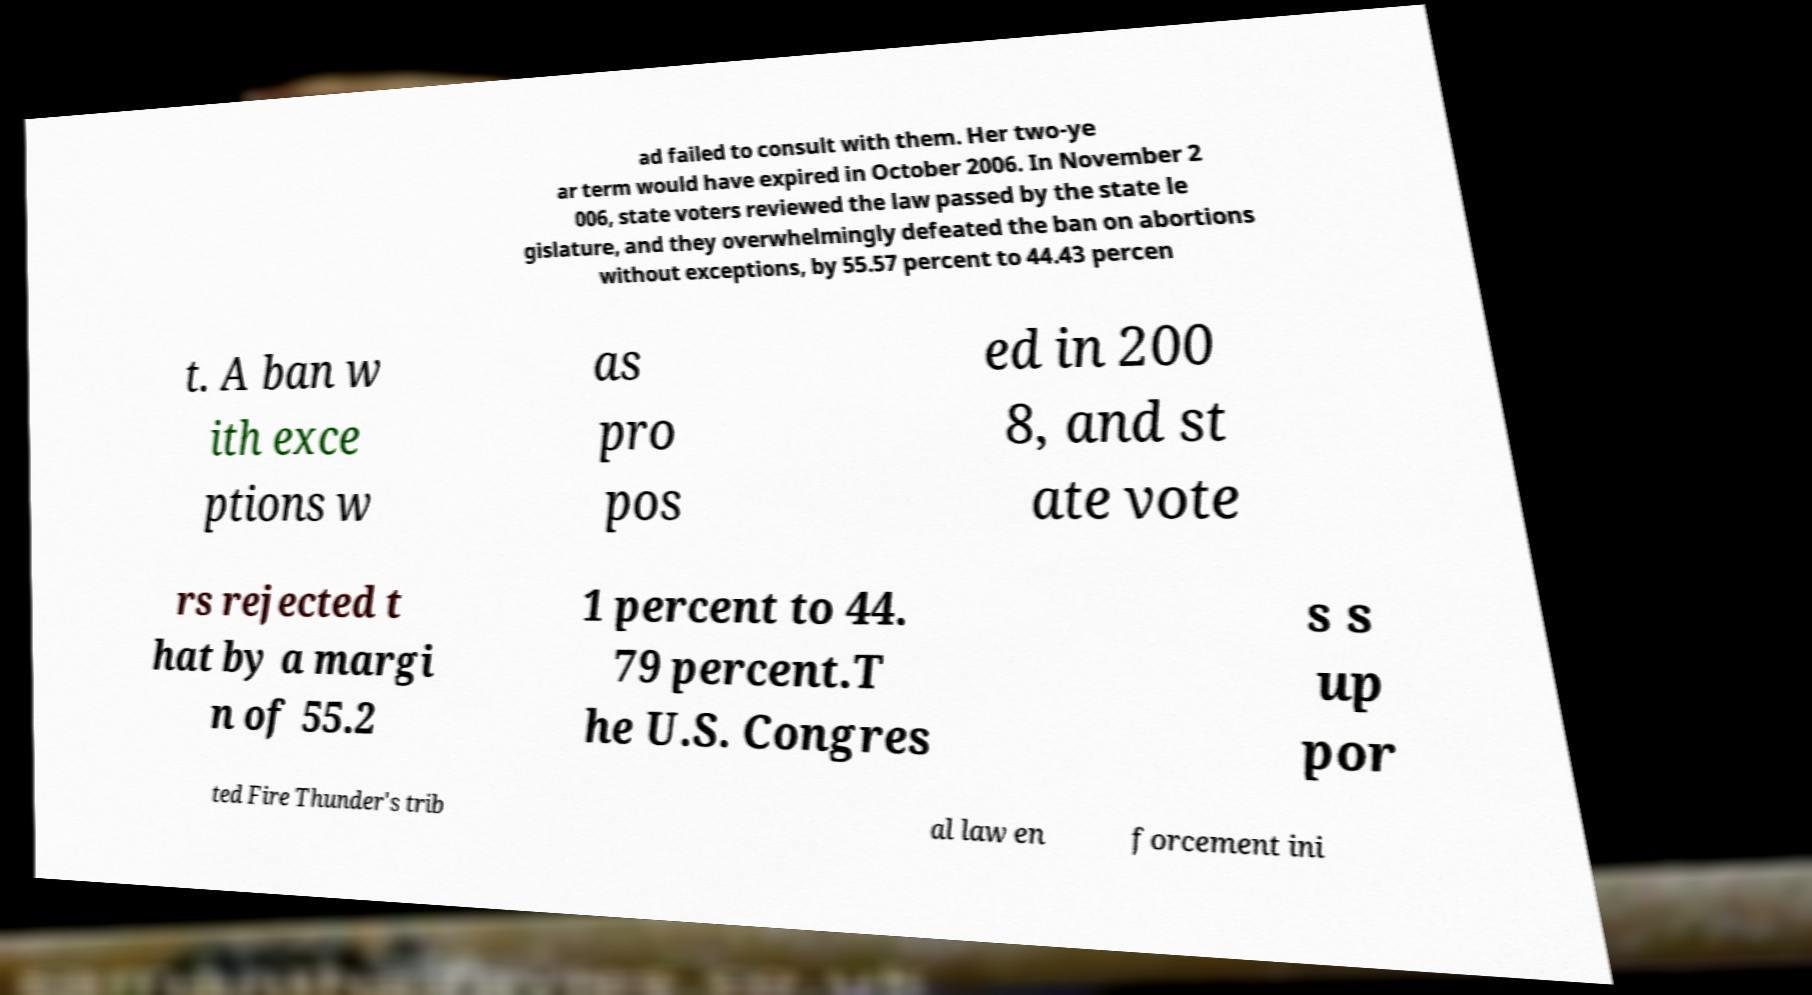I need the written content from this picture converted into text. Can you do that? ad failed to consult with them. Her two-ye ar term would have expired in October 2006. In November 2 006, state voters reviewed the law passed by the state le gislature, and they overwhelmingly defeated the ban on abortions without exceptions, by 55.57 percent to 44.43 percen t. A ban w ith exce ptions w as pro pos ed in 200 8, and st ate vote rs rejected t hat by a margi n of 55.2 1 percent to 44. 79 percent.T he U.S. Congres s s up por ted Fire Thunder's trib al law en forcement ini 